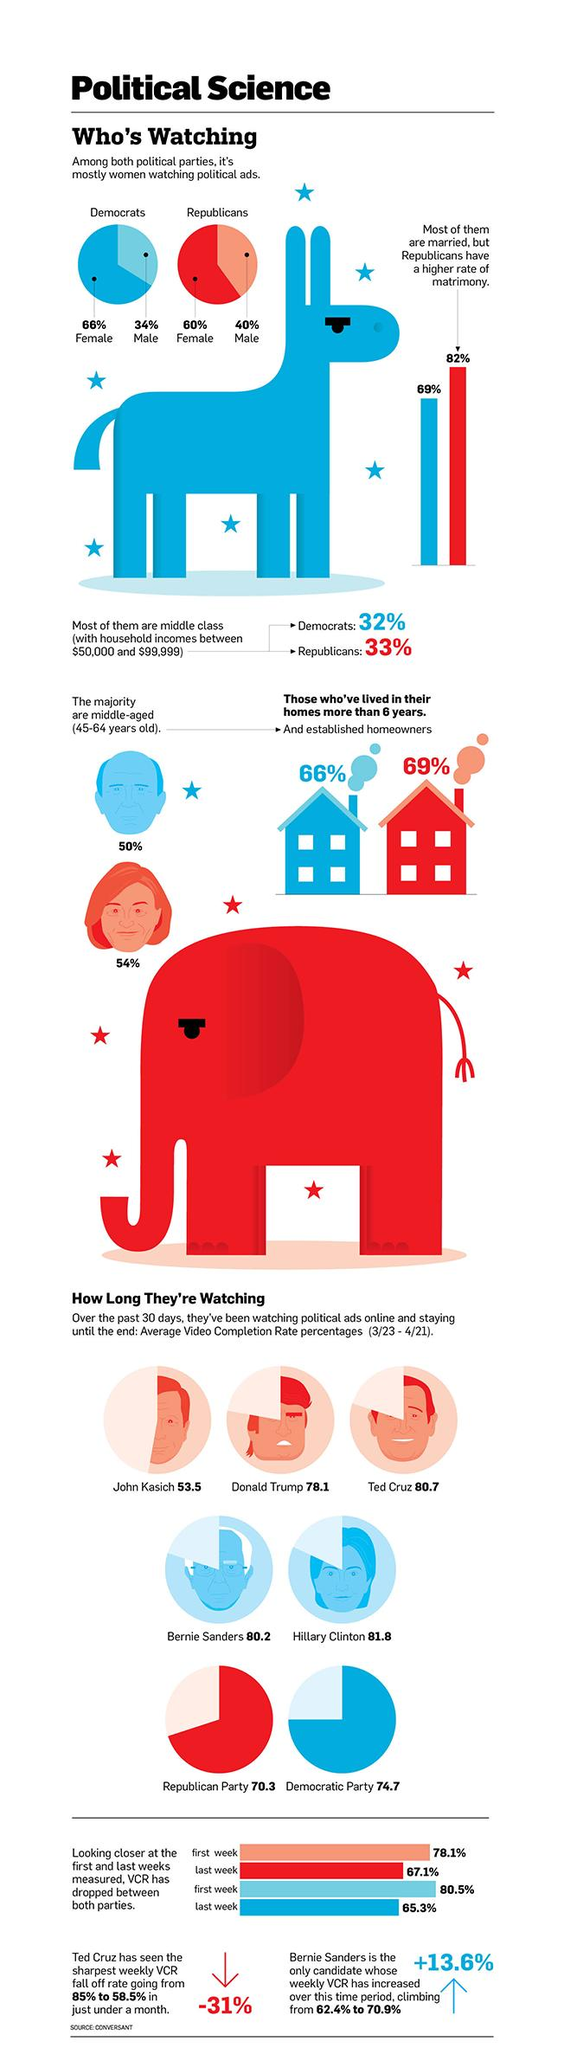Specify some key components in this picture. According to a survey, 66% of Democratic women reported watching political ads. According to the survey, 60% of Republican women reported watching political ads. Approximately 32% of Democratic voters in the United States fall into the middle class with a household income between $50,000 and $99,999. According to a survey, Democrats have a lower rate of marriage compared to other political parties. According to a survey, the marriage rate among Democrats is 69%. 